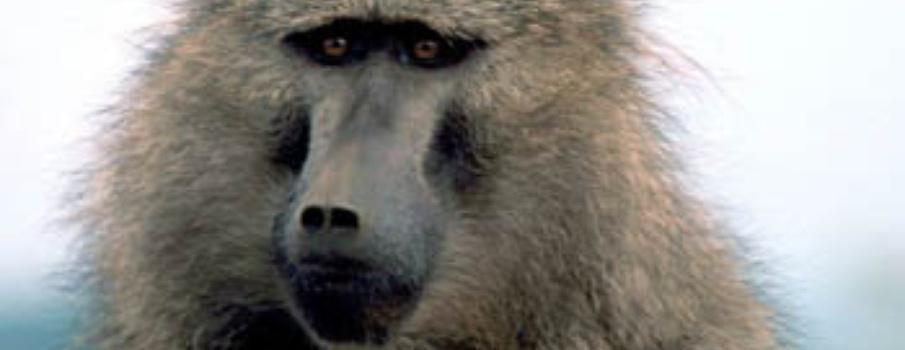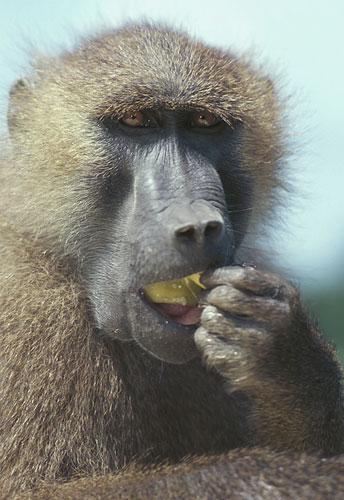The first image is the image on the left, the second image is the image on the right. Considering the images on both sides, is "One monkey is showing its teeth" valid? Answer yes or no. No. 